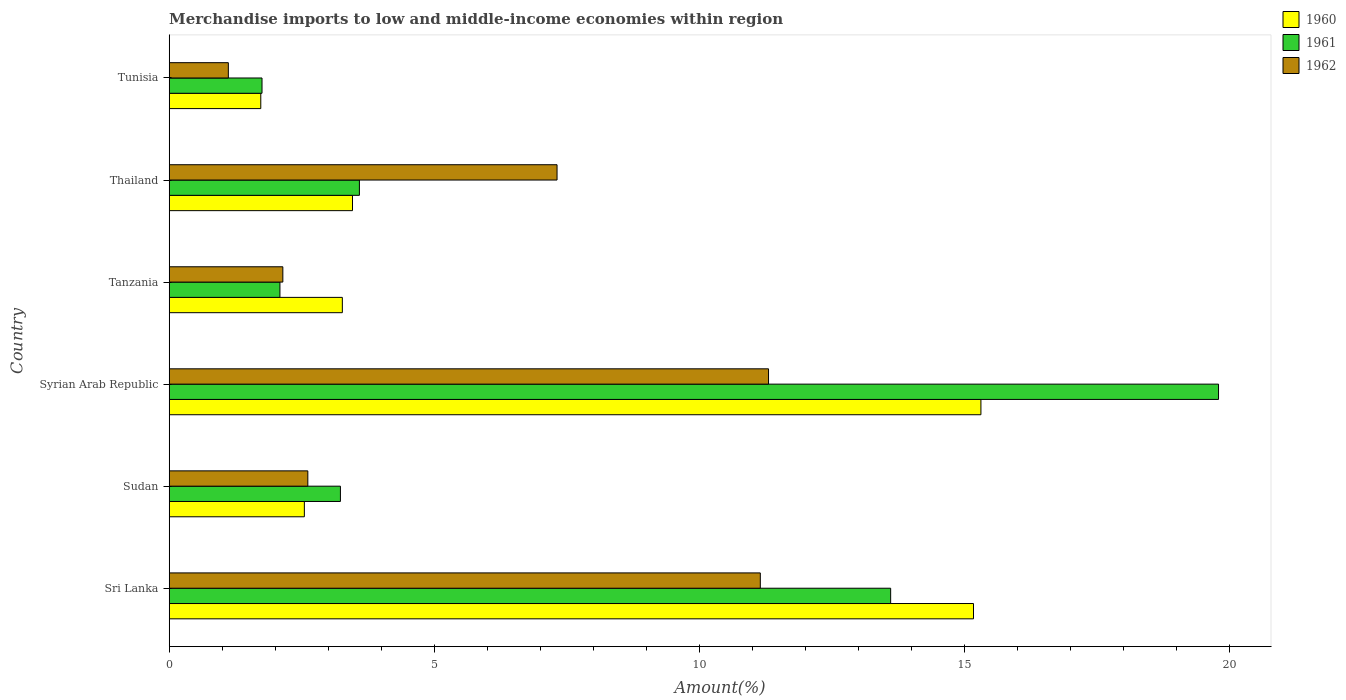How many different coloured bars are there?
Make the answer very short. 3. How many groups of bars are there?
Offer a very short reply. 6. Are the number of bars on each tick of the Y-axis equal?
Make the answer very short. Yes. What is the label of the 2nd group of bars from the top?
Offer a terse response. Thailand. In how many cases, is the number of bars for a given country not equal to the number of legend labels?
Make the answer very short. 0. What is the percentage of amount earned from merchandise imports in 1961 in Thailand?
Provide a succinct answer. 3.59. Across all countries, what is the maximum percentage of amount earned from merchandise imports in 1961?
Your response must be concise. 19.79. Across all countries, what is the minimum percentage of amount earned from merchandise imports in 1962?
Your answer should be compact. 1.12. In which country was the percentage of amount earned from merchandise imports in 1961 maximum?
Your answer should be compact. Syrian Arab Republic. In which country was the percentage of amount earned from merchandise imports in 1961 minimum?
Your answer should be very brief. Tunisia. What is the total percentage of amount earned from merchandise imports in 1961 in the graph?
Your answer should be very brief. 44.04. What is the difference between the percentage of amount earned from merchandise imports in 1961 in Sri Lanka and that in Tunisia?
Provide a short and direct response. 11.85. What is the difference between the percentage of amount earned from merchandise imports in 1962 in Tanzania and the percentage of amount earned from merchandise imports in 1960 in Syrian Arab Republic?
Ensure brevity in your answer.  -13.16. What is the average percentage of amount earned from merchandise imports in 1960 per country?
Your answer should be very brief. 6.91. What is the difference between the percentage of amount earned from merchandise imports in 1961 and percentage of amount earned from merchandise imports in 1962 in Tanzania?
Keep it short and to the point. -0.05. What is the ratio of the percentage of amount earned from merchandise imports in 1960 in Sudan to that in Tanzania?
Give a very brief answer. 0.78. Is the percentage of amount earned from merchandise imports in 1960 in Sudan less than that in Tanzania?
Your answer should be compact. Yes. Is the difference between the percentage of amount earned from merchandise imports in 1961 in Sri Lanka and Tanzania greater than the difference between the percentage of amount earned from merchandise imports in 1962 in Sri Lanka and Tanzania?
Keep it short and to the point. Yes. What is the difference between the highest and the second highest percentage of amount earned from merchandise imports in 1961?
Make the answer very short. 6.18. What is the difference between the highest and the lowest percentage of amount earned from merchandise imports in 1962?
Ensure brevity in your answer.  10.19. Is the sum of the percentage of amount earned from merchandise imports in 1960 in Sri Lanka and Tunisia greater than the maximum percentage of amount earned from merchandise imports in 1961 across all countries?
Your answer should be compact. No. What does the 3rd bar from the top in Sudan represents?
Ensure brevity in your answer.  1960. What does the 1st bar from the bottom in Thailand represents?
Your answer should be very brief. 1960. Are the values on the major ticks of X-axis written in scientific E-notation?
Provide a succinct answer. No. Does the graph contain any zero values?
Provide a succinct answer. No. Does the graph contain grids?
Provide a short and direct response. No. Where does the legend appear in the graph?
Your response must be concise. Top right. How are the legend labels stacked?
Provide a short and direct response. Vertical. What is the title of the graph?
Give a very brief answer. Merchandise imports to low and middle-income economies within region. What is the label or title of the X-axis?
Your response must be concise. Amount(%). What is the Amount(%) of 1960 in Sri Lanka?
Keep it short and to the point. 15.17. What is the Amount(%) of 1961 in Sri Lanka?
Your answer should be compact. 13.6. What is the Amount(%) in 1962 in Sri Lanka?
Provide a succinct answer. 11.15. What is the Amount(%) in 1960 in Sudan?
Offer a terse response. 2.55. What is the Amount(%) of 1961 in Sudan?
Make the answer very short. 3.23. What is the Amount(%) in 1962 in Sudan?
Keep it short and to the point. 2.61. What is the Amount(%) in 1960 in Syrian Arab Republic?
Offer a terse response. 15.31. What is the Amount(%) of 1961 in Syrian Arab Republic?
Make the answer very short. 19.79. What is the Amount(%) of 1962 in Syrian Arab Republic?
Provide a short and direct response. 11.3. What is the Amount(%) in 1960 in Tanzania?
Provide a short and direct response. 3.26. What is the Amount(%) in 1961 in Tanzania?
Keep it short and to the point. 2.09. What is the Amount(%) in 1962 in Tanzania?
Give a very brief answer. 2.14. What is the Amount(%) of 1960 in Thailand?
Give a very brief answer. 3.46. What is the Amount(%) in 1961 in Thailand?
Offer a terse response. 3.59. What is the Amount(%) in 1962 in Thailand?
Provide a short and direct response. 7.31. What is the Amount(%) in 1960 in Tunisia?
Ensure brevity in your answer.  1.73. What is the Amount(%) of 1961 in Tunisia?
Provide a short and direct response. 1.75. What is the Amount(%) in 1962 in Tunisia?
Offer a terse response. 1.12. Across all countries, what is the maximum Amount(%) of 1960?
Give a very brief answer. 15.31. Across all countries, what is the maximum Amount(%) in 1961?
Your answer should be compact. 19.79. Across all countries, what is the maximum Amount(%) in 1962?
Give a very brief answer. 11.3. Across all countries, what is the minimum Amount(%) of 1960?
Ensure brevity in your answer.  1.73. Across all countries, what is the minimum Amount(%) of 1961?
Keep it short and to the point. 1.75. Across all countries, what is the minimum Amount(%) of 1962?
Offer a terse response. 1.12. What is the total Amount(%) in 1960 in the graph?
Your answer should be compact. 41.47. What is the total Amount(%) of 1961 in the graph?
Your response must be concise. 44.04. What is the total Amount(%) of 1962 in the graph?
Provide a short and direct response. 35.63. What is the difference between the Amount(%) in 1960 in Sri Lanka and that in Sudan?
Ensure brevity in your answer.  12.62. What is the difference between the Amount(%) of 1961 in Sri Lanka and that in Sudan?
Your answer should be compact. 10.38. What is the difference between the Amount(%) of 1962 in Sri Lanka and that in Sudan?
Provide a succinct answer. 8.53. What is the difference between the Amount(%) in 1960 in Sri Lanka and that in Syrian Arab Republic?
Your response must be concise. -0.14. What is the difference between the Amount(%) of 1961 in Sri Lanka and that in Syrian Arab Republic?
Keep it short and to the point. -6.18. What is the difference between the Amount(%) in 1962 in Sri Lanka and that in Syrian Arab Republic?
Make the answer very short. -0.16. What is the difference between the Amount(%) of 1960 in Sri Lanka and that in Tanzania?
Your answer should be compact. 11.9. What is the difference between the Amount(%) in 1961 in Sri Lanka and that in Tanzania?
Make the answer very short. 11.52. What is the difference between the Amount(%) in 1962 in Sri Lanka and that in Tanzania?
Provide a short and direct response. 9. What is the difference between the Amount(%) in 1960 in Sri Lanka and that in Thailand?
Keep it short and to the point. 11.71. What is the difference between the Amount(%) in 1961 in Sri Lanka and that in Thailand?
Keep it short and to the point. 10.02. What is the difference between the Amount(%) of 1962 in Sri Lanka and that in Thailand?
Keep it short and to the point. 3.83. What is the difference between the Amount(%) in 1960 in Sri Lanka and that in Tunisia?
Offer a very short reply. 13.44. What is the difference between the Amount(%) in 1961 in Sri Lanka and that in Tunisia?
Make the answer very short. 11.85. What is the difference between the Amount(%) in 1962 in Sri Lanka and that in Tunisia?
Provide a short and direct response. 10.03. What is the difference between the Amount(%) in 1960 in Sudan and that in Syrian Arab Republic?
Your response must be concise. -12.76. What is the difference between the Amount(%) of 1961 in Sudan and that in Syrian Arab Republic?
Keep it short and to the point. -16.56. What is the difference between the Amount(%) of 1962 in Sudan and that in Syrian Arab Republic?
Offer a terse response. -8.69. What is the difference between the Amount(%) in 1960 in Sudan and that in Tanzania?
Make the answer very short. -0.72. What is the difference between the Amount(%) of 1961 in Sudan and that in Tanzania?
Your answer should be very brief. 1.14. What is the difference between the Amount(%) in 1962 in Sudan and that in Tanzania?
Your answer should be compact. 0.47. What is the difference between the Amount(%) in 1960 in Sudan and that in Thailand?
Your answer should be very brief. -0.91. What is the difference between the Amount(%) in 1961 in Sudan and that in Thailand?
Provide a short and direct response. -0.36. What is the difference between the Amount(%) of 1962 in Sudan and that in Thailand?
Your answer should be compact. -4.7. What is the difference between the Amount(%) in 1960 in Sudan and that in Tunisia?
Provide a short and direct response. 0.82. What is the difference between the Amount(%) of 1961 in Sudan and that in Tunisia?
Ensure brevity in your answer.  1.48. What is the difference between the Amount(%) of 1962 in Sudan and that in Tunisia?
Ensure brevity in your answer.  1.5. What is the difference between the Amount(%) in 1960 in Syrian Arab Republic and that in Tanzania?
Provide a short and direct response. 12.04. What is the difference between the Amount(%) in 1961 in Syrian Arab Republic and that in Tanzania?
Give a very brief answer. 17.7. What is the difference between the Amount(%) in 1962 in Syrian Arab Republic and that in Tanzania?
Ensure brevity in your answer.  9.16. What is the difference between the Amount(%) in 1960 in Syrian Arab Republic and that in Thailand?
Offer a very short reply. 11.85. What is the difference between the Amount(%) of 1961 in Syrian Arab Republic and that in Thailand?
Your response must be concise. 16.2. What is the difference between the Amount(%) of 1962 in Syrian Arab Republic and that in Thailand?
Your answer should be very brief. 3.99. What is the difference between the Amount(%) of 1960 in Syrian Arab Republic and that in Tunisia?
Your answer should be very brief. 13.58. What is the difference between the Amount(%) in 1961 in Syrian Arab Republic and that in Tunisia?
Provide a short and direct response. 18.04. What is the difference between the Amount(%) in 1962 in Syrian Arab Republic and that in Tunisia?
Your answer should be compact. 10.19. What is the difference between the Amount(%) of 1960 in Tanzania and that in Thailand?
Your answer should be very brief. -0.19. What is the difference between the Amount(%) of 1961 in Tanzania and that in Thailand?
Make the answer very short. -1.5. What is the difference between the Amount(%) in 1962 in Tanzania and that in Thailand?
Make the answer very short. -5.17. What is the difference between the Amount(%) in 1960 in Tanzania and that in Tunisia?
Your answer should be compact. 1.54. What is the difference between the Amount(%) in 1961 in Tanzania and that in Tunisia?
Offer a very short reply. 0.34. What is the difference between the Amount(%) of 1962 in Tanzania and that in Tunisia?
Offer a terse response. 1.03. What is the difference between the Amount(%) of 1960 in Thailand and that in Tunisia?
Your response must be concise. 1.73. What is the difference between the Amount(%) of 1961 in Thailand and that in Tunisia?
Your response must be concise. 1.84. What is the difference between the Amount(%) in 1962 in Thailand and that in Tunisia?
Provide a short and direct response. 6.2. What is the difference between the Amount(%) of 1960 in Sri Lanka and the Amount(%) of 1961 in Sudan?
Make the answer very short. 11.94. What is the difference between the Amount(%) in 1960 in Sri Lanka and the Amount(%) in 1962 in Sudan?
Your answer should be compact. 12.55. What is the difference between the Amount(%) of 1961 in Sri Lanka and the Amount(%) of 1962 in Sudan?
Your answer should be very brief. 10.99. What is the difference between the Amount(%) of 1960 in Sri Lanka and the Amount(%) of 1961 in Syrian Arab Republic?
Ensure brevity in your answer.  -4.62. What is the difference between the Amount(%) of 1960 in Sri Lanka and the Amount(%) of 1962 in Syrian Arab Republic?
Your answer should be very brief. 3.87. What is the difference between the Amount(%) in 1961 in Sri Lanka and the Amount(%) in 1962 in Syrian Arab Republic?
Provide a short and direct response. 2.3. What is the difference between the Amount(%) in 1960 in Sri Lanka and the Amount(%) in 1961 in Tanzania?
Ensure brevity in your answer.  13.08. What is the difference between the Amount(%) in 1960 in Sri Lanka and the Amount(%) in 1962 in Tanzania?
Ensure brevity in your answer.  13.02. What is the difference between the Amount(%) in 1961 in Sri Lanka and the Amount(%) in 1962 in Tanzania?
Your answer should be compact. 11.46. What is the difference between the Amount(%) of 1960 in Sri Lanka and the Amount(%) of 1961 in Thailand?
Make the answer very short. 11.58. What is the difference between the Amount(%) of 1960 in Sri Lanka and the Amount(%) of 1962 in Thailand?
Provide a short and direct response. 7.85. What is the difference between the Amount(%) of 1961 in Sri Lanka and the Amount(%) of 1962 in Thailand?
Your answer should be compact. 6.29. What is the difference between the Amount(%) in 1960 in Sri Lanka and the Amount(%) in 1961 in Tunisia?
Keep it short and to the point. 13.42. What is the difference between the Amount(%) in 1960 in Sri Lanka and the Amount(%) in 1962 in Tunisia?
Your answer should be very brief. 14.05. What is the difference between the Amount(%) in 1961 in Sri Lanka and the Amount(%) in 1962 in Tunisia?
Give a very brief answer. 12.49. What is the difference between the Amount(%) in 1960 in Sudan and the Amount(%) in 1961 in Syrian Arab Republic?
Offer a terse response. -17.24. What is the difference between the Amount(%) in 1960 in Sudan and the Amount(%) in 1962 in Syrian Arab Republic?
Your response must be concise. -8.75. What is the difference between the Amount(%) in 1961 in Sudan and the Amount(%) in 1962 in Syrian Arab Republic?
Give a very brief answer. -8.07. What is the difference between the Amount(%) in 1960 in Sudan and the Amount(%) in 1961 in Tanzania?
Your answer should be very brief. 0.46. What is the difference between the Amount(%) of 1960 in Sudan and the Amount(%) of 1962 in Tanzania?
Make the answer very short. 0.41. What is the difference between the Amount(%) in 1961 in Sudan and the Amount(%) in 1962 in Tanzania?
Offer a very short reply. 1.09. What is the difference between the Amount(%) in 1960 in Sudan and the Amount(%) in 1961 in Thailand?
Offer a terse response. -1.04. What is the difference between the Amount(%) in 1960 in Sudan and the Amount(%) in 1962 in Thailand?
Keep it short and to the point. -4.76. What is the difference between the Amount(%) of 1961 in Sudan and the Amount(%) of 1962 in Thailand?
Provide a short and direct response. -4.08. What is the difference between the Amount(%) of 1960 in Sudan and the Amount(%) of 1961 in Tunisia?
Your response must be concise. 0.8. What is the difference between the Amount(%) in 1960 in Sudan and the Amount(%) in 1962 in Tunisia?
Make the answer very short. 1.43. What is the difference between the Amount(%) in 1961 in Sudan and the Amount(%) in 1962 in Tunisia?
Ensure brevity in your answer.  2.11. What is the difference between the Amount(%) in 1960 in Syrian Arab Republic and the Amount(%) in 1961 in Tanzania?
Offer a terse response. 13.22. What is the difference between the Amount(%) of 1960 in Syrian Arab Republic and the Amount(%) of 1962 in Tanzania?
Make the answer very short. 13.16. What is the difference between the Amount(%) of 1961 in Syrian Arab Republic and the Amount(%) of 1962 in Tanzania?
Provide a succinct answer. 17.64. What is the difference between the Amount(%) in 1960 in Syrian Arab Republic and the Amount(%) in 1961 in Thailand?
Your response must be concise. 11.72. What is the difference between the Amount(%) of 1960 in Syrian Arab Republic and the Amount(%) of 1962 in Thailand?
Your answer should be compact. 7.99. What is the difference between the Amount(%) of 1961 in Syrian Arab Republic and the Amount(%) of 1962 in Thailand?
Give a very brief answer. 12.47. What is the difference between the Amount(%) in 1960 in Syrian Arab Republic and the Amount(%) in 1961 in Tunisia?
Ensure brevity in your answer.  13.56. What is the difference between the Amount(%) of 1960 in Syrian Arab Republic and the Amount(%) of 1962 in Tunisia?
Make the answer very short. 14.19. What is the difference between the Amount(%) in 1961 in Syrian Arab Republic and the Amount(%) in 1962 in Tunisia?
Make the answer very short. 18.67. What is the difference between the Amount(%) of 1960 in Tanzania and the Amount(%) of 1961 in Thailand?
Ensure brevity in your answer.  -0.32. What is the difference between the Amount(%) of 1960 in Tanzania and the Amount(%) of 1962 in Thailand?
Make the answer very short. -4.05. What is the difference between the Amount(%) in 1961 in Tanzania and the Amount(%) in 1962 in Thailand?
Offer a terse response. -5.23. What is the difference between the Amount(%) in 1960 in Tanzania and the Amount(%) in 1961 in Tunisia?
Your response must be concise. 1.51. What is the difference between the Amount(%) of 1960 in Tanzania and the Amount(%) of 1962 in Tunisia?
Offer a terse response. 2.15. What is the difference between the Amount(%) in 1961 in Tanzania and the Amount(%) in 1962 in Tunisia?
Make the answer very short. 0.97. What is the difference between the Amount(%) of 1960 in Thailand and the Amount(%) of 1961 in Tunisia?
Your response must be concise. 1.71. What is the difference between the Amount(%) in 1960 in Thailand and the Amount(%) in 1962 in Tunisia?
Make the answer very short. 2.34. What is the difference between the Amount(%) in 1961 in Thailand and the Amount(%) in 1962 in Tunisia?
Provide a succinct answer. 2.47. What is the average Amount(%) in 1960 per country?
Your response must be concise. 6.91. What is the average Amount(%) of 1961 per country?
Ensure brevity in your answer.  7.34. What is the average Amount(%) in 1962 per country?
Provide a short and direct response. 5.94. What is the difference between the Amount(%) in 1960 and Amount(%) in 1961 in Sri Lanka?
Provide a succinct answer. 1.56. What is the difference between the Amount(%) in 1960 and Amount(%) in 1962 in Sri Lanka?
Your response must be concise. 4.02. What is the difference between the Amount(%) of 1961 and Amount(%) of 1962 in Sri Lanka?
Your answer should be very brief. 2.46. What is the difference between the Amount(%) in 1960 and Amount(%) in 1961 in Sudan?
Provide a short and direct response. -0.68. What is the difference between the Amount(%) in 1960 and Amount(%) in 1962 in Sudan?
Ensure brevity in your answer.  -0.07. What is the difference between the Amount(%) of 1961 and Amount(%) of 1962 in Sudan?
Your answer should be compact. 0.61. What is the difference between the Amount(%) of 1960 and Amount(%) of 1961 in Syrian Arab Republic?
Your answer should be very brief. -4.48. What is the difference between the Amount(%) in 1960 and Amount(%) in 1962 in Syrian Arab Republic?
Make the answer very short. 4.01. What is the difference between the Amount(%) of 1961 and Amount(%) of 1962 in Syrian Arab Republic?
Your answer should be very brief. 8.49. What is the difference between the Amount(%) in 1960 and Amount(%) in 1961 in Tanzania?
Provide a short and direct response. 1.18. What is the difference between the Amount(%) of 1960 and Amount(%) of 1962 in Tanzania?
Your answer should be compact. 1.12. What is the difference between the Amount(%) in 1961 and Amount(%) in 1962 in Tanzania?
Your answer should be compact. -0.05. What is the difference between the Amount(%) of 1960 and Amount(%) of 1961 in Thailand?
Ensure brevity in your answer.  -0.13. What is the difference between the Amount(%) in 1960 and Amount(%) in 1962 in Thailand?
Keep it short and to the point. -3.86. What is the difference between the Amount(%) of 1961 and Amount(%) of 1962 in Thailand?
Make the answer very short. -3.73. What is the difference between the Amount(%) of 1960 and Amount(%) of 1961 in Tunisia?
Provide a short and direct response. -0.02. What is the difference between the Amount(%) of 1960 and Amount(%) of 1962 in Tunisia?
Keep it short and to the point. 0.61. What is the difference between the Amount(%) in 1961 and Amount(%) in 1962 in Tunisia?
Provide a short and direct response. 0.64. What is the ratio of the Amount(%) in 1960 in Sri Lanka to that in Sudan?
Your answer should be compact. 5.95. What is the ratio of the Amount(%) of 1961 in Sri Lanka to that in Sudan?
Offer a very short reply. 4.21. What is the ratio of the Amount(%) of 1962 in Sri Lanka to that in Sudan?
Your answer should be very brief. 4.26. What is the ratio of the Amount(%) in 1961 in Sri Lanka to that in Syrian Arab Republic?
Keep it short and to the point. 0.69. What is the ratio of the Amount(%) in 1962 in Sri Lanka to that in Syrian Arab Republic?
Give a very brief answer. 0.99. What is the ratio of the Amount(%) of 1960 in Sri Lanka to that in Tanzania?
Keep it short and to the point. 4.65. What is the ratio of the Amount(%) of 1961 in Sri Lanka to that in Tanzania?
Your answer should be very brief. 6.51. What is the ratio of the Amount(%) in 1962 in Sri Lanka to that in Tanzania?
Keep it short and to the point. 5.2. What is the ratio of the Amount(%) of 1960 in Sri Lanka to that in Thailand?
Offer a terse response. 4.39. What is the ratio of the Amount(%) of 1961 in Sri Lanka to that in Thailand?
Offer a very short reply. 3.79. What is the ratio of the Amount(%) of 1962 in Sri Lanka to that in Thailand?
Offer a very short reply. 1.52. What is the ratio of the Amount(%) of 1960 in Sri Lanka to that in Tunisia?
Provide a succinct answer. 8.78. What is the ratio of the Amount(%) in 1961 in Sri Lanka to that in Tunisia?
Your answer should be very brief. 7.77. What is the ratio of the Amount(%) in 1962 in Sri Lanka to that in Tunisia?
Offer a terse response. 9.99. What is the ratio of the Amount(%) of 1960 in Sudan to that in Syrian Arab Republic?
Your response must be concise. 0.17. What is the ratio of the Amount(%) of 1961 in Sudan to that in Syrian Arab Republic?
Your response must be concise. 0.16. What is the ratio of the Amount(%) of 1962 in Sudan to that in Syrian Arab Republic?
Keep it short and to the point. 0.23. What is the ratio of the Amount(%) of 1960 in Sudan to that in Tanzania?
Your answer should be compact. 0.78. What is the ratio of the Amount(%) in 1961 in Sudan to that in Tanzania?
Ensure brevity in your answer.  1.55. What is the ratio of the Amount(%) in 1962 in Sudan to that in Tanzania?
Keep it short and to the point. 1.22. What is the ratio of the Amount(%) in 1960 in Sudan to that in Thailand?
Offer a terse response. 0.74. What is the ratio of the Amount(%) of 1961 in Sudan to that in Thailand?
Make the answer very short. 0.9. What is the ratio of the Amount(%) of 1962 in Sudan to that in Thailand?
Provide a short and direct response. 0.36. What is the ratio of the Amount(%) in 1960 in Sudan to that in Tunisia?
Make the answer very short. 1.48. What is the ratio of the Amount(%) of 1961 in Sudan to that in Tunisia?
Offer a terse response. 1.84. What is the ratio of the Amount(%) in 1962 in Sudan to that in Tunisia?
Offer a terse response. 2.34. What is the ratio of the Amount(%) of 1960 in Syrian Arab Republic to that in Tanzania?
Offer a terse response. 4.69. What is the ratio of the Amount(%) in 1961 in Syrian Arab Republic to that in Tanzania?
Your answer should be compact. 9.48. What is the ratio of the Amount(%) of 1962 in Syrian Arab Republic to that in Tanzania?
Make the answer very short. 5.27. What is the ratio of the Amount(%) of 1960 in Syrian Arab Republic to that in Thailand?
Offer a very short reply. 4.43. What is the ratio of the Amount(%) in 1961 in Syrian Arab Republic to that in Thailand?
Offer a very short reply. 5.52. What is the ratio of the Amount(%) in 1962 in Syrian Arab Republic to that in Thailand?
Offer a terse response. 1.55. What is the ratio of the Amount(%) in 1960 in Syrian Arab Republic to that in Tunisia?
Make the answer very short. 8.86. What is the ratio of the Amount(%) of 1961 in Syrian Arab Republic to that in Tunisia?
Provide a succinct answer. 11.31. What is the ratio of the Amount(%) in 1962 in Syrian Arab Republic to that in Tunisia?
Your response must be concise. 10.13. What is the ratio of the Amount(%) in 1960 in Tanzania to that in Thailand?
Your answer should be compact. 0.94. What is the ratio of the Amount(%) of 1961 in Tanzania to that in Thailand?
Your response must be concise. 0.58. What is the ratio of the Amount(%) in 1962 in Tanzania to that in Thailand?
Ensure brevity in your answer.  0.29. What is the ratio of the Amount(%) of 1960 in Tanzania to that in Tunisia?
Your response must be concise. 1.89. What is the ratio of the Amount(%) of 1961 in Tanzania to that in Tunisia?
Offer a very short reply. 1.19. What is the ratio of the Amount(%) of 1962 in Tanzania to that in Tunisia?
Give a very brief answer. 1.92. What is the ratio of the Amount(%) in 1960 in Thailand to that in Tunisia?
Give a very brief answer. 2. What is the ratio of the Amount(%) of 1961 in Thailand to that in Tunisia?
Provide a short and direct response. 2.05. What is the ratio of the Amount(%) in 1962 in Thailand to that in Tunisia?
Make the answer very short. 6.56. What is the difference between the highest and the second highest Amount(%) in 1960?
Your answer should be very brief. 0.14. What is the difference between the highest and the second highest Amount(%) in 1961?
Keep it short and to the point. 6.18. What is the difference between the highest and the second highest Amount(%) of 1962?
Keep it short and to the point. 0.16. What is the difference between the highest and the lowest Amount(%) of 1960?
Keep it short and to the point. 13.58. What is the difference between the highest and the lowest Amount(%) in 1961?
Offer a very short reply. 18.04. What is the difference between the highest and the lowest Amount(%) in 1962?
Keep it short and to the point. 10.19. 